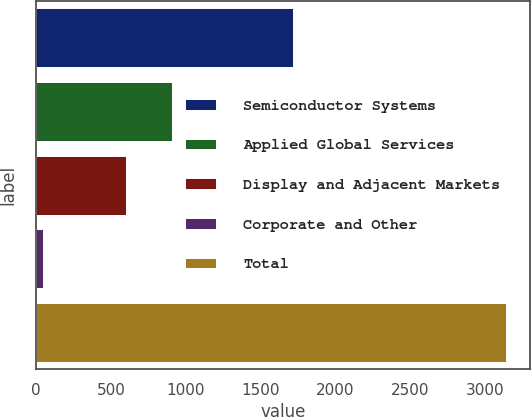<chart> <loc_0><loc_0><loc_500><loc_500><bar_chart><fcel>Semiconductor Systems<fcel>Applied Global Services<fcel>Display and Adjacent Markets<fcel>Corporate and Other<fcel>Total<nl><fcel>1720<fcel>907.7<fcel>598<fcel>45<fcel>3142<nl></chart> 